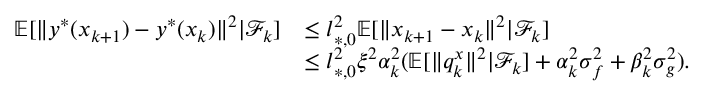Convert formula to latex. <formula><loc_0><loc_0><loc_500><loc_500>\begin{array} { r l } { \mathbb { E } [ \| y ^ { * } ( x _ { k + 1 } ) - y ^ { * } ( x _ { k } ) \| ^ { 2 } | \mathcal { F } _ { k } ] } & { \leq l _ { * , 0 } ^ { 2 } \mathbb { E } [ \| x _ { k + 1 } - x _ { k } \| ^ { 2 } | \mathcal { F } _ { k } ] } \\ & { \leq l _ { * , 0 } ^ { 2 } \xi ^ { 2 } \alpha _ { k } ^ { 2 } ( \mathbb { E } [ \| q _ { k } ^ { x } \| ^ { 2 } | \mathcal { F } _ { k } ] + \alpha _ { k } ^ { 2 } \sigma _ { f } ^ { 2 } + \beta _ { k } ^ { 2 } \sigma _ { g } ^ { 2 } ) . } \end{array}</formula> 